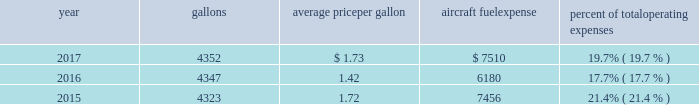( 2 ) our union-represented mainline employees are covered by agreements that are not currently amendable .
Joint collective bargaining agreements ( jcbas ) have been reached with post-merger employee groups , except the maintenance , fleet service , stock clerks , maintenance control technicians and maintenance training instructors represented by the twu-iam association who are covered by separate cbas that become amendable in the third quarter of 2018 .
Until those agreements become amendable , negotiations for jcbas will be conducted outside the traditional rla bargaining process as described above , and , in the meantime , no self-help will be permissible .
( 3 ) among our wholly-owned regional subsidiaries , the psa mechanics and flight attendants have agreements that are now amendable and are engaged in traditional rla negotiations .
The envoy passenger service employees are engaged in traditional rla negotiations for an initial cba .
The piedmont fleet and passenger service employees have reached a tentative five-year agreement which is subject to membership ratification .
For more discussion , see part i , item 1a .
Risk factors 2013 201cunion disputes , employee strikes and other labor-related disruptions may adversely affect our operations . 201d aircraft fuel our operations and financial results are significantly affected by the availability and price of jet fuel , which is our second largest expense .
Based on our 2018 forecasted mainline and regional fuel consumption , we estimate that a one cent per gallon increase in aviation fuel price would increase our 2018 annual fuel expense by $ 45 million .
The table shows annual aircraft fuel consumption and costs , including taxes , for our mainline and regional operations for 2017 , 2016 and 2015 ( gallons and aircraft fuel expense in millions ) .
Year gallons average price per gallon aircraft fuel expense percent of total operating expenses .
As of december 31 , 2017 , we did not have any fuel hedging contracts outstanding to hedge our fuel consumption .
As such , and assuming we do not enter into any future transactions to hedge our fuel consumption , we will continue to be fully exposed to fluctuations in fuel prices .
Our current policy is not to enter into transactions to hedge our fuel consumption , although we review that policy from time to time based on market conditions and other factors .
Fuel prices have fluctuated substantially over the past several years .
We cannot predict the future availability , price volatility or cost of aircraft fuel .
Natural disasters ( including hurricanes or similar events in the u.s .
Southeast and on the gulf coast where a significant portion of domestic refining capacity is located ) , political disruptions or wars involving oil-producing countries , changes in fuel-related governmental policy , the strength of the u.s .
Dollar against foreign currencies , changes in access to petroleum product pipelines and terminals , speculation in the energy futures markets , changes in aircraft fuel production capacity , environmental concerns and other unpredictable events may result in fuel supply shortages , distribution challenges , additional fuel price volatility and cost increases in the future .
See part i , item 1a .
Risk factors 2013 201cour business is very dependent on the price and availability of aircraft fuel .
Continued periods of high volatility in fuel costs , increased fuel prices or significant disruptions in the supply of aircraft fuel could have a significant negative impact on our operating results and liquidity . 201d seasonality and other factors due to the greater demand for air travel during the summer months , revenues in the airline industry in the second and third quarters of the year tend to be greater than revenues in the first and fourth quarters of the year .
General economic conditions , fears of terrorism or war , fare initiatives , fluctuations in fuel prices , labor actions , weather , natural disasters , outbreaks of disease and other factors could impact this seasonal pattern .
Therefore , our quarterly results of operations are not necessarily indicative of operating results for the entire year , and historical operating results in a quarterly or annual period are not necessarily indicative of future operating results. .
What is the percentage change in the average price per gallon of aircraft fuel from 2016 to 2017? 
Computations: ((1.73 - 1.42) / 1.42)
Answer: 0.21831. 